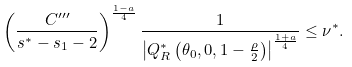Convert formula to latex. <formula><loc_0><loc_0><loc_500><loc_500>\left ( \frac { C ^ { \prime \prime \prime } } { s ^ { \ast } - s _ { 1 } - 2 } \right ) ^ { \frac { 1 - a } { 4 } } \frac { 1 } { \left | Q ^ { \ast } _ { R } \left ( \theta _ { 0 } , 0 , 1 - \frac { \rho } { 2 } \right ) \right | ^ { \frac { 1 + a } { 4 } } } \leq \nu ^ { \ast } .</formula> 